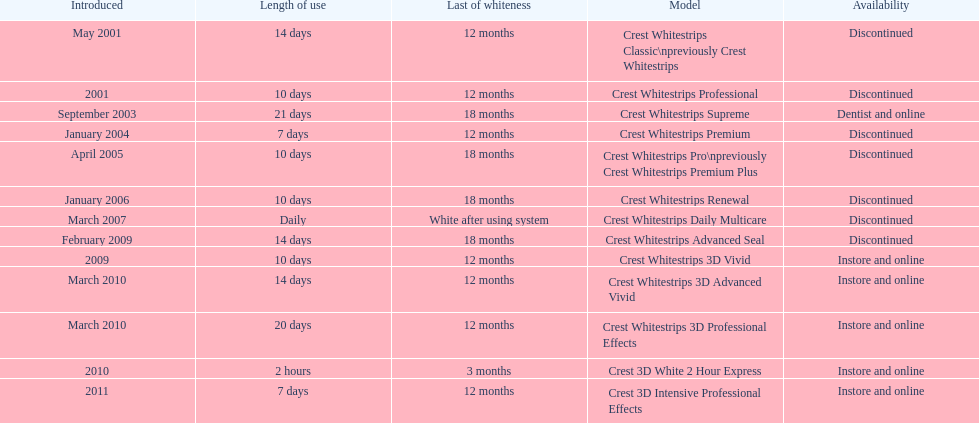Does the crest white strips pro last as long as the crest white strips renewal? Yes. Would you be able to parse every entry in this table? {'header': ['Introduced', 'Length of use', 'Last of whiteness', 'Model', 'Availability'], 'rows': [['May 2001', '14 days', '12 months', 'Crest Whitestrips Classic\\npreviously Crest Whitestrips', 'Discontinued'], ['2001', '10 days', '12 months', 'Crest Whitestrips Professional', 'Discontinued'], ['September 2003', '21 days', '18 months', 'Crest Whitestrips Supreme', 'Dentist and online'], ['January 2004', '7 days', '12 months', 'Crest Whitestrips Premium', 'Discontinued'], ['April 2005', '10 days', '18 months', 'Crest Whitestrips Pro\\npreviously Crest Whitestrips Premium Plus', 'Discontinued'], ['January 2006', '10 days', '18 months', 'Crest Whitestrips Renewal', 'Discontinued'], ['March 2007', 'Daily', 'White after using system', 'Crest Whitestrips Daily Multicare', 'Discontinued'], ['February 2009', '14 days', '18 months', 'Crest Whitestrips Advanced Seal', 'Discontinued'], ['2009', '10 days', '12 months', 'Crest Whitestrips 3D Vivid', 'Instore and online'], ['March 2010', '14 days', '12 months', 'Crest Whitestrips 3D Advanced Vivid', 'Instore and online'], ['March 2010', '20 days', '12 months', 'Crest Whitestrips 3D Professional Effects', 'Instore and online'], ['2010', '2 hours', '3 months', 'Crest 3D White 2 Hour Express', 'Instore and online'], ['2011', '7 days', '12 months', 'Crest 3D Intensive Professional Effects', 'Instore and online']]} 